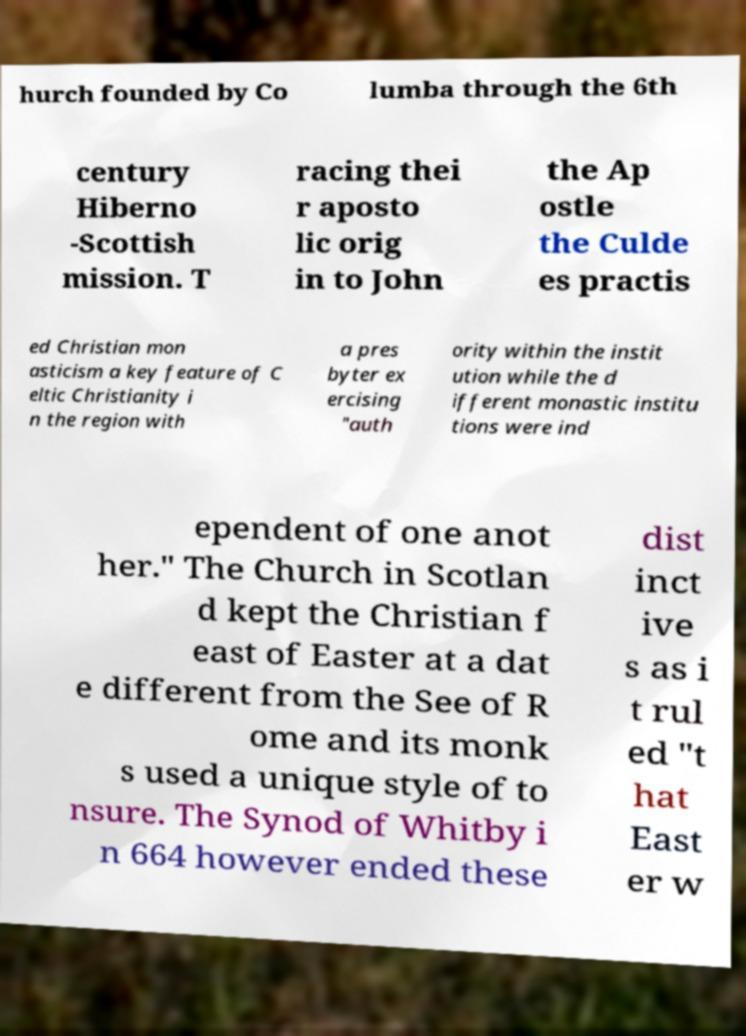What messages or text are displayed in this image? I need them in a readable, typed format. hurch founded by Co lumba through the 6th century Hiberno -Scottish mission. T racing thei r aposto lic orig in to John the Ap ostle the Culde es practis ed Christian mon asticism a key feature of C eltic Christianity i n the region with a pres byter ex ercising "auth ority within the instit ution while the d ifferent monastic institu tions were ind ependent of one anot her." The Church in Scotlan d kept the Christian f east of Easter at a dat e different from the See of R ome and its monk s used a unique style of to nsure. The Synod of Whitby i n 664 however ended these dist inct ive s as i t rul ed "t hat East er w 